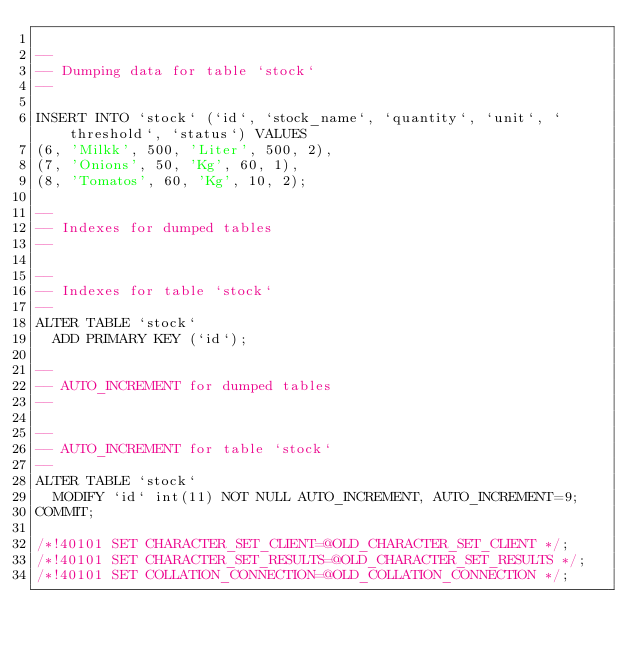Convert code to text. <code><loc_0><loc_0><loc_500><loc_500><_SQL_>
--
-- Dumping data for table `stock`
--

INSERT INTO `stock` (`id`, `stock_name`, `quantity`, `unit`, `threshold`, `status`) VALUES
(6, 'Milkk', 500, 'Liter', 500, 2),
(7, 'Onions', 50, 'Kg', 60, 1),
(8, 'Tomatos', 60, 'Kg', 10, 2);

--
-- Indexes for dumped tables
--

--
-- Indexes for table `stock`
--
ALTER TABLE `stock`
  ADD PRIMARY KEY (`id`);

--
-- AUTO_INCREMENT for dumped tables
--

--
-- AUTO_INCREMENT for table `stock`
--
ALTER TABLE `stock`
  MODIFY `id` int(11) NOT NULL AUTO_INCREMENT, AUTO_INCREMENT=9;
COMMIT;

/*!40101 SET CHARACTER_SET_CLIENT=@OLD_CHARACTER_SET_CLIENT */;
/*!40101 SET CHARACTER_SET_RESULTS=@OLD_CHARACTER_SET_RESULTS */;
/*!40101 SET COLLATION_CONNECTION=@OLD_COLLATION_CONNECTION */;
</code> 